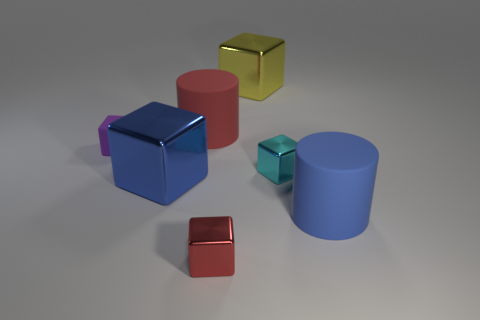Add 3 small gray blocks. How many objects exist? 10 Subtract all big yellow blocks. How many blocks are left? 4 Subtract all red blocks. How many blocks are left? 4 Subtract all cylinders. How many objects are left? 5 Subtract all large metallic things. Subtract all rubber things. How many objects are left? 2 Add 5 big cylinders. How many big cylinders are left? 7 Add 2 blue rubber cylinders. How many blue rubber cylinders exist? 3 Subtract 1 cyan blocks. How many objects are left? 6 Subtract all red blocks. Subtract all red cylinders. How many blocks are left? 4 